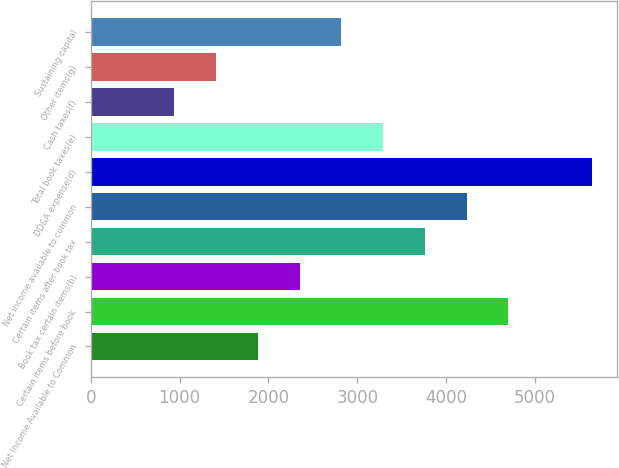<chart> <loc_0><loc_0><loc_500><loc_500><bar_chart><fcel>Net Income Available to Common<fcel>Certain items before book<fcel>Book tax certain items(b)<fcel>Certain items after book tax<fcel>Net income available to common<fcel>DD&A expense(d)<fcel>Total book taxes(e)<fcel>Cash taxes(f)<fcel>Other items(g)<fcel>Sustaining capital<nl><fcel>1880.56<fcel>4699<fcel>2350.3<fcel>3759.52<fcel>4229.26<fcel>5638.48<fcel>3289.78<fcel>941.08<fcel>1410.82<fcel>2820.04<nl></chart> 